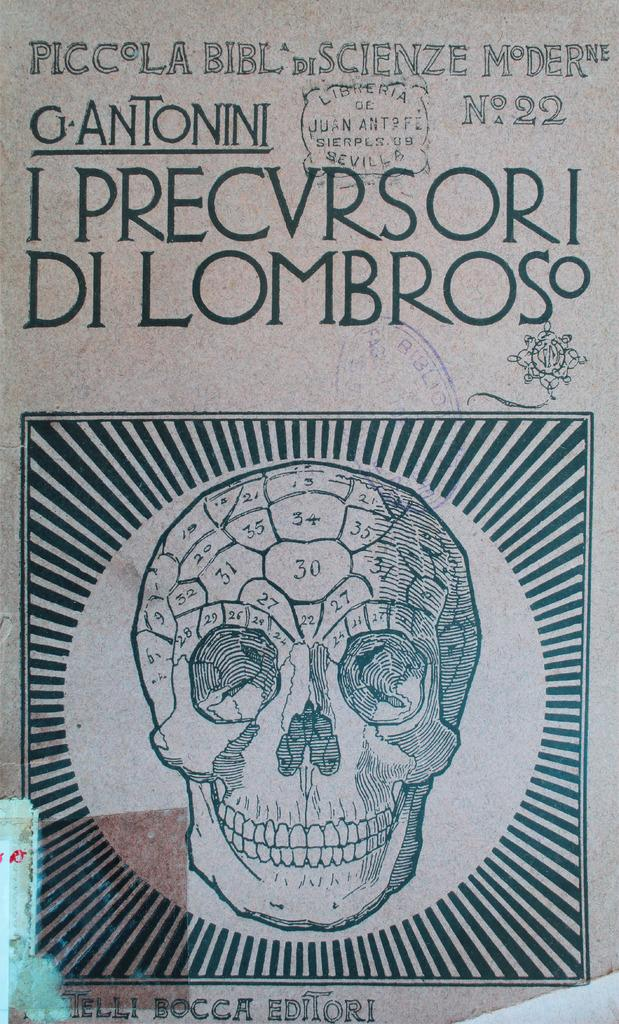<image>
Present a compact description of the photo's key features. A book in another language with the words I PRECVRSORI DI LOMBROS on it. 